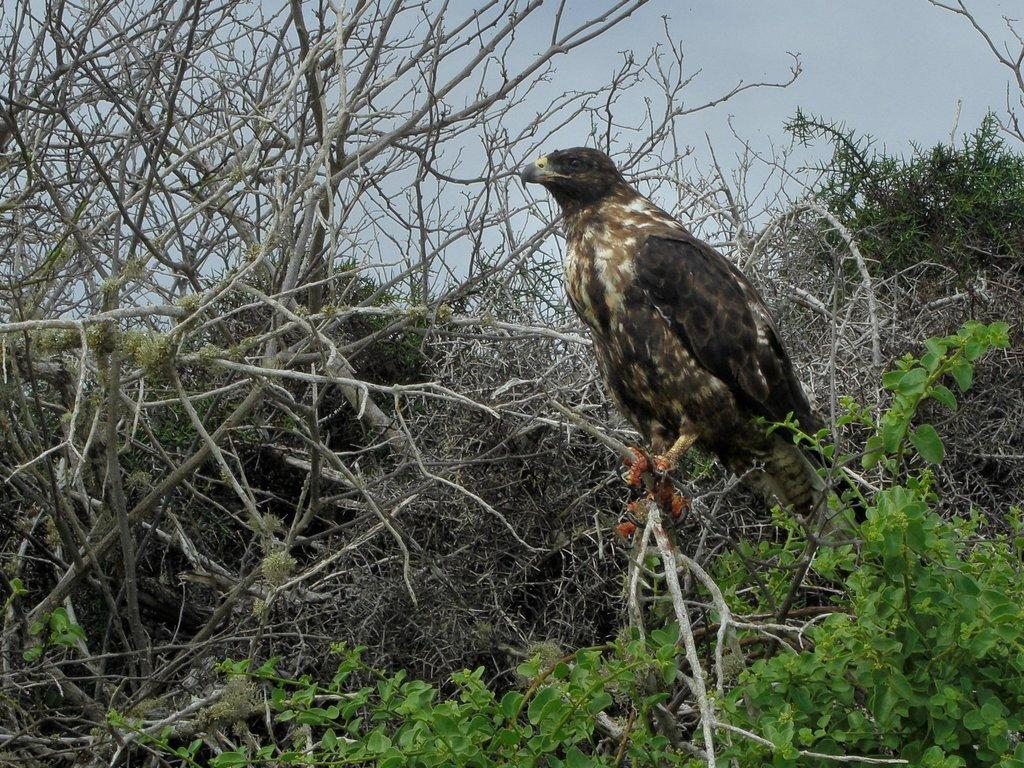What type of animal is present in the image? There is a bird in the image. What can be seen in the background of the image? There are trees and the sky visible in the background of the image. What type of lunch is the bird eating in the image? There is no lunch present in the image; it only features a bird. What type of corn can be seen growing in the image? There is no corn present in the image; it only features a bird and the background. 